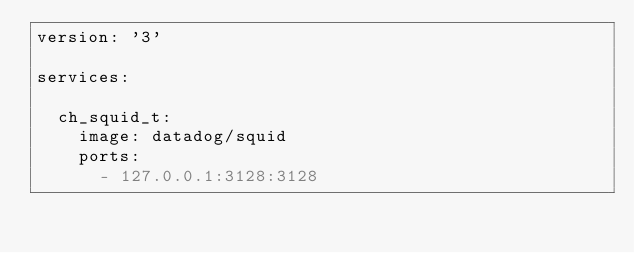Convert code to text. <code><loc_0><loc_0><loc_500><loc_500><_YAML_>version: '3'

services:

  ch_squid_t:
    image: datadog/squid
    ports:
      - 127.0.0.1:3128:3128
</code> 